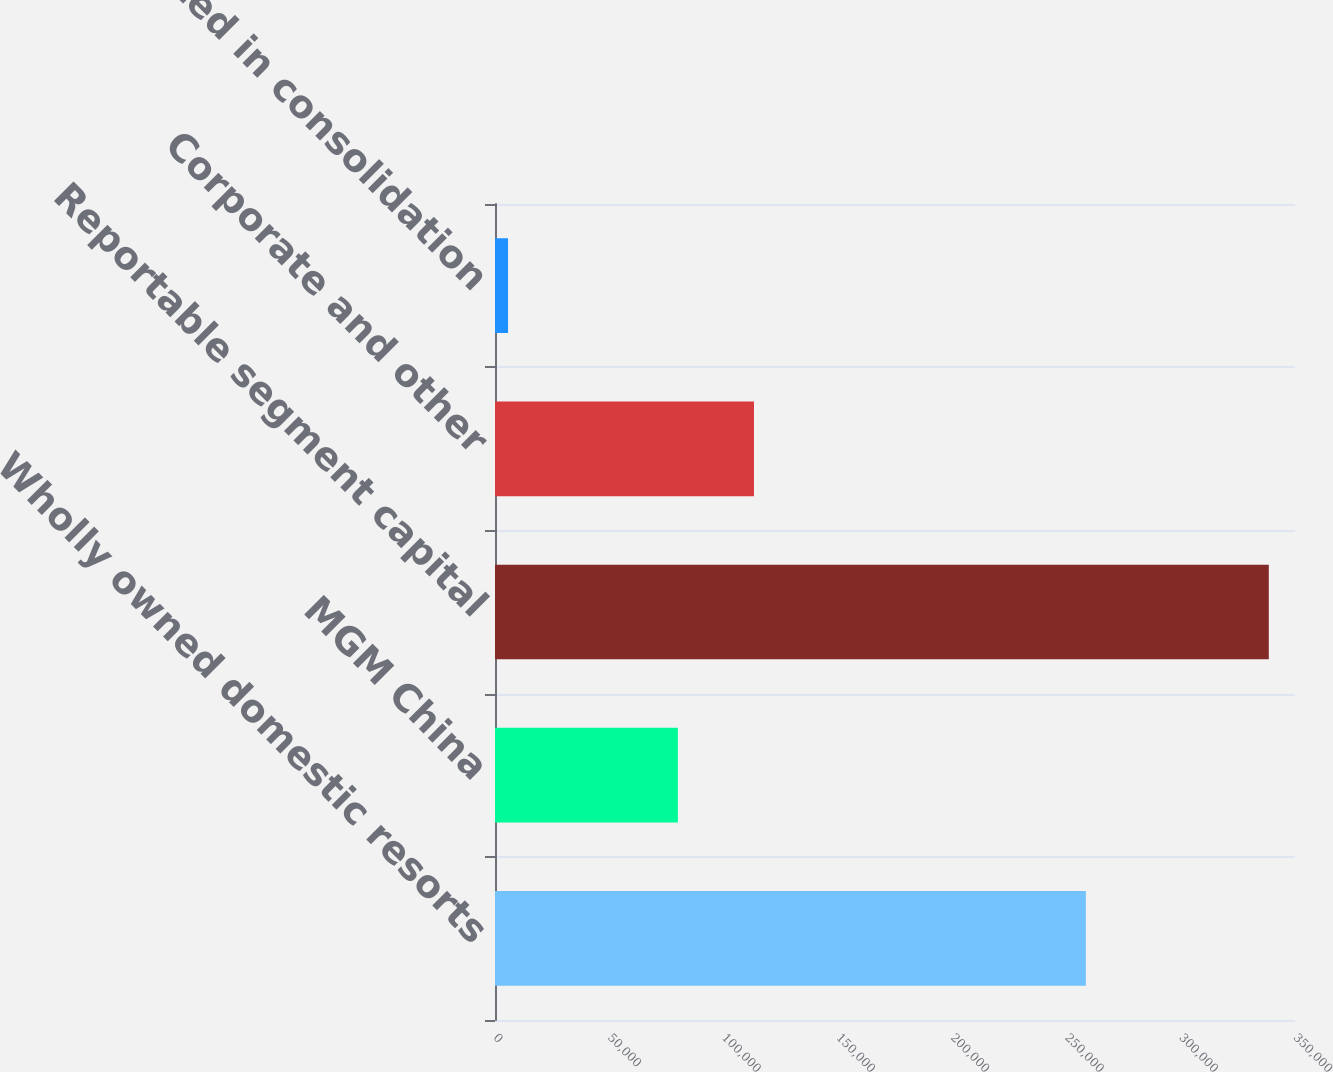Convert chart. <chart><loc_0><loc_0><loc_500><loc_500><bar_chart><fcel>Wholly owned domestic resorts<fcel>MGM China<fcel>Reportable segment capital<fcel>Corporate and other<fcel>Eliminated in consolidation<nl><fcel>258519<fcel>80018<fcel>338537<fcel>113301<fcel>5709<nl></chart> 